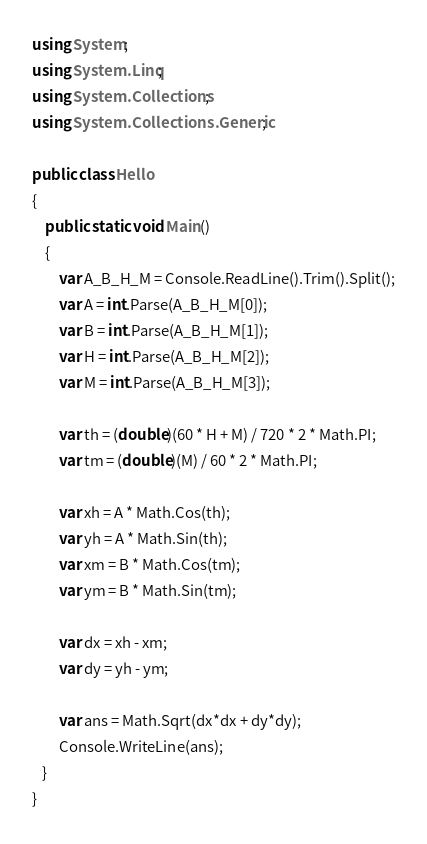Convert code to text. <code><loc_0><loc_0><loc_500><loc_500><_C#_>using System;
using System.Linq;
using System.Collections;
using System.Collections.Generic;

public class Hello
{
    public static void Main()
    {
        var A_B_H_M = Console.ReadLine().Trim().Split();
        var A = int.Parse(A_B_H_M[0]);
        var B = int.Parse(A_B_H_M[1]);        
        var H = int.Parse(A_B_H_M[2]);        
        var M = int.Parse(A_B_H_M[3]);        

        var th = (double)(60 * H + M) / 720 * 2 * Math.PI;
        var tm = (double)(M) / 60 * 2 * Math.PI;

        var xh = A * Math.Cos(th);
        var yh = A * Math.Sin(th);
        var xm = B * Math.Cos(tm);
        var ym = B * Math.Sin(tm);
        
        var dx = xh - xm;
        var dy = yh - ym;

        var ans = Math.Sqrt(dx*dx + dy*dy);
        Console.WriteLine(ans);
   }
}</code> 